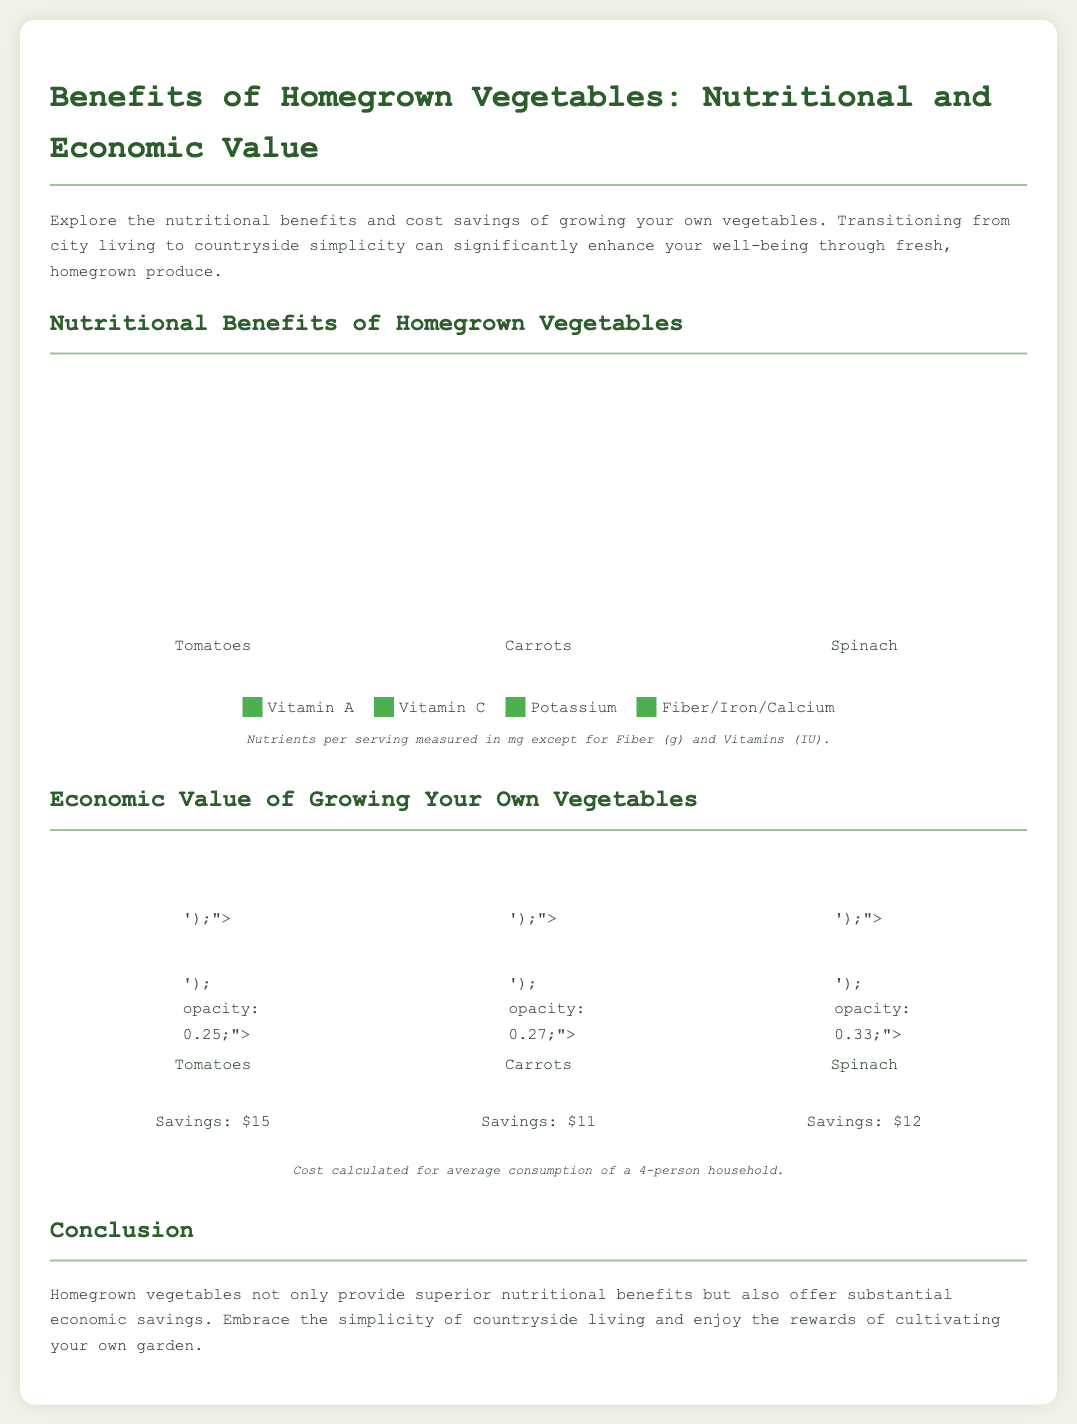What vegetable has the highest Vitamin A measurement? The bar chart shows that Spinach has the highest Vitamin A measurement with a height of 563%.
Answer: Spinach What savings can be achieved by growing tomatoes? The pictorial chart indicates that growing tomatoes provides savings of $15.
Answer: $15 Which vegetable has the lowest Vitamin C measurement? Looking at the bar graph, Tomatoes have the lowest Vitamin C measurement with a height of 15%.
Answer: Tomatoes What is the combined savings from carrots and spinach? The total savings from Carrots ($11) and Spinach ($12) is calculated as $11 + $12 = $23.
Answer: $23 How much Fiber/Iron/Calcium is present in Carrots? In the bar chart, Carrots contain 28% of Fiber/Iron/Calcium.
Answer: 28% Which vegetable shows the highest amount of Potassium? The bar chart illustrates that Tomatoes have the highest amount of Potassium with a height of 237%.
Answer: Tomatoes What cost is calculated for? In the note, it's indicated that the cost is calculated for the average consumption of a 4-person household.
Answer: 4-person household What is the overall message of the infographic? The conclusion section emphasizes the nutritional and economic benefits of homegrown vegetables.
Answer: Nutritional and economic benefits What is the color of the pictorial item representing Spinach? The pictorial item representing Spinach is shown in a green color.
Answer: Green 